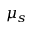<formula> <loc_0><loc_0><loc_500><loc_500>\mu _ { s }</formula> 